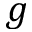<formula> <loc_0><loc_0><loc_500><loc_500>g</formula> 